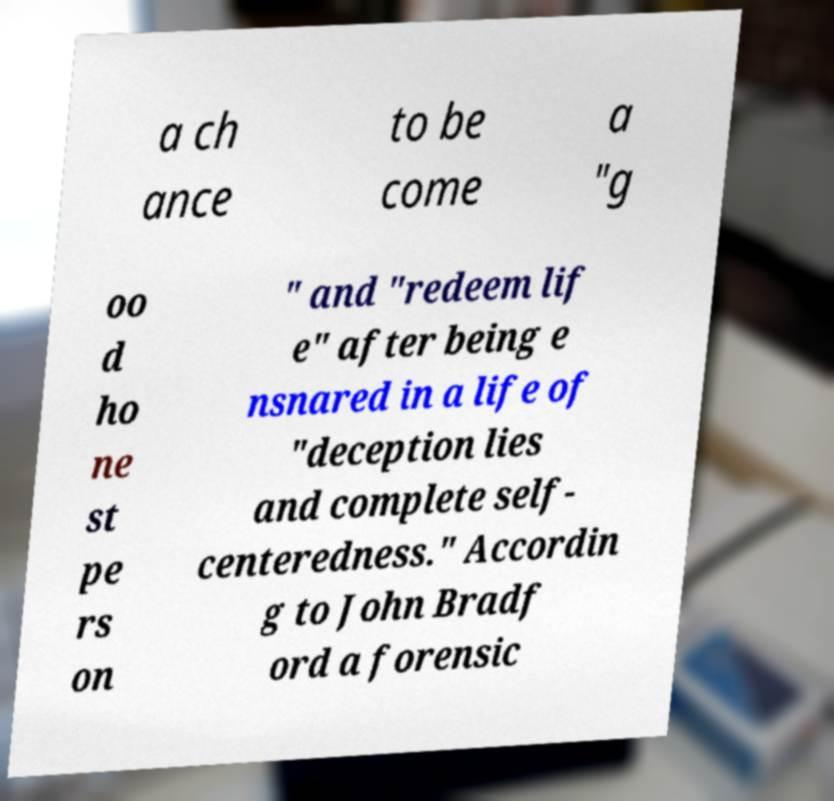For documentation purposes, I need the text within this image transcribed. Could you provide that? a ch ance to be come a "g oo d ho ne st pe rs on " and "redeem lif e" after being e nsnared in a life of "deception lies and complete self- centeredness." Accordin g to John Bradf ord a forensic 